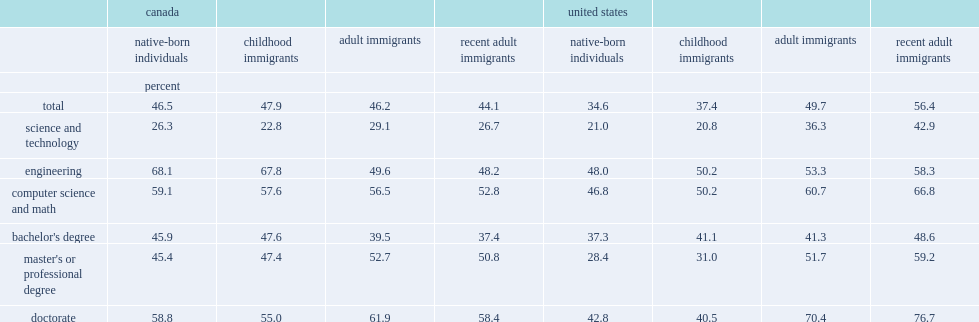Would you mind parsing the complete table? {'header': ['', 'canada', '', '', '', 'united states', '', '', ''], 'rows': [['', 'native-born individuals', 'childhood immigrants', 'adult immigrants', 'recent adult immigrants', 'native-born individuals', 'childhood immigrants', 'adult immigrants', 'recent adult immigrants'], ['', 'percent', '', '', '', '', '', '', ''], ['total', '46.5', '47.9', '46.2', '44.1', '34.6', '37.4', '49.7', '56.4'], ['science and technology', '26.3', '22.8', '29.1', '26.7', '21.0', '20.8', '36.3', '42.9'], ['engineering', '68.1', '67.8', '49.6', '48.2', '48.0', '50.2', '53.3', '58.3'], ['computer science and math', '59.1', '57.6', '56.5', '52.8', '46.8', '50.2', '60.7', '66.8'], ["bachelor's degree", '45.9', '47.6', '39.5', '37.4', '37.3', '41.1', '41.3', '48.6'], ["master's or professional degree", '45.4', '47.4', '52.7', '50.8', '28.4', '31.0', '51.7', '59.2'], ['doctorate', '58.8', '55.0', '61.9', '58.4', '42.8', '40.5', '70.4', '76.7']]} In canada (in 2016), how many percent of stem-educated adult immigrant workers had a stem occupation in canada? 46.2. In the united states (from 2015 to 2017), how many percent of stem-educated adult immigrant workers had a stem occupation in the united states? 49.7. How many percent in stem jobs in canada the native-born population and immigrants achieved? 46.5. How many percent in stem jobs in the united states the native-born population and immigrants achieved? 34.6. 